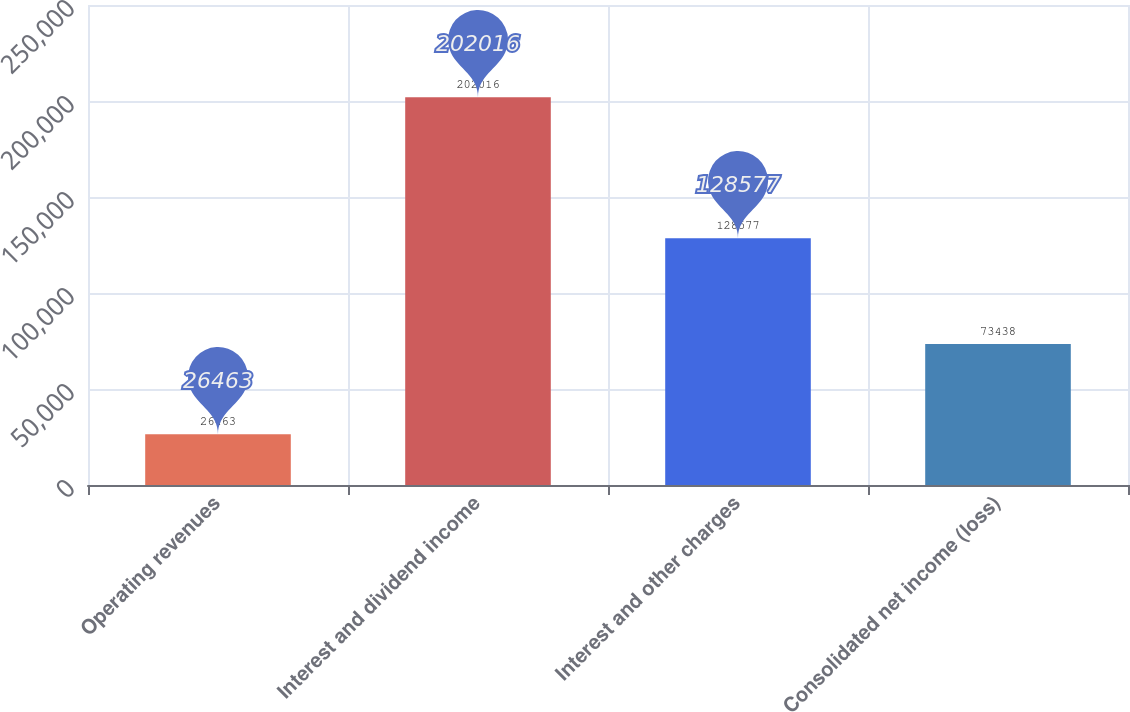<chart> <loc_0><loc_0><loc_500><loc_500><bar_chart><fcel>Operating revenues<fcel>Interest and dividend income<fcel>Interest and other charges<fcel>Consolidated net income (loss)<nl><fcel>26463<fcel>202016<fcel>128577<fcel>73438<nl></chart> 